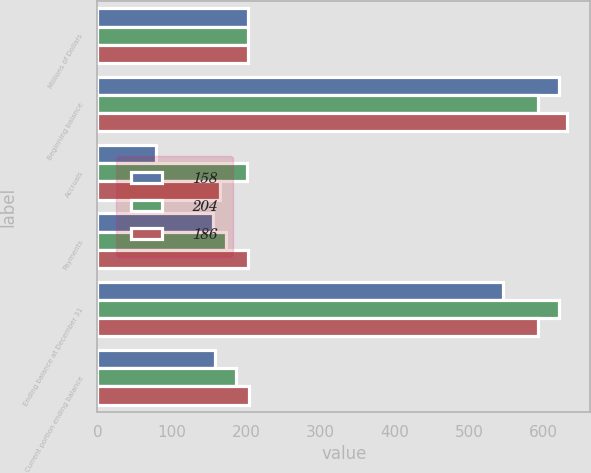<chart> <loc_0><loc_0><loc_500><loc_500><stacked_bar_chart><ecel><fcel>Millions of Dollars<fcel>Beginning balance<fcel>Accruals<fcel>Payments<fcel>Ending balance at December 31<fcel>Current portion ending balance<nl><fcel>158<fcel>203<fcel>621<fcel>79<fcel>155<fcel>545<fcel>158<nl><fcel>204<fcel>203<fcel>593<fcel>201<fcel>173<fcel>621<fcel>186<nl><fcel>186<fcel>203<fcel>631<fcel>165<fcel>203<fcel>593<fcel>204<nl></chart> 